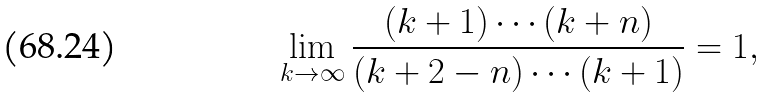Convert formula to latex. <formula><loc_0><loc_0><loc_500><loc_500>\lim _ { k \to \infty } \frac { ( k + 1 ) \cdots ( k + n ) } { ( k + 2 - n ) \cdots ( k + 1 ) } = 1 ,</formula> 